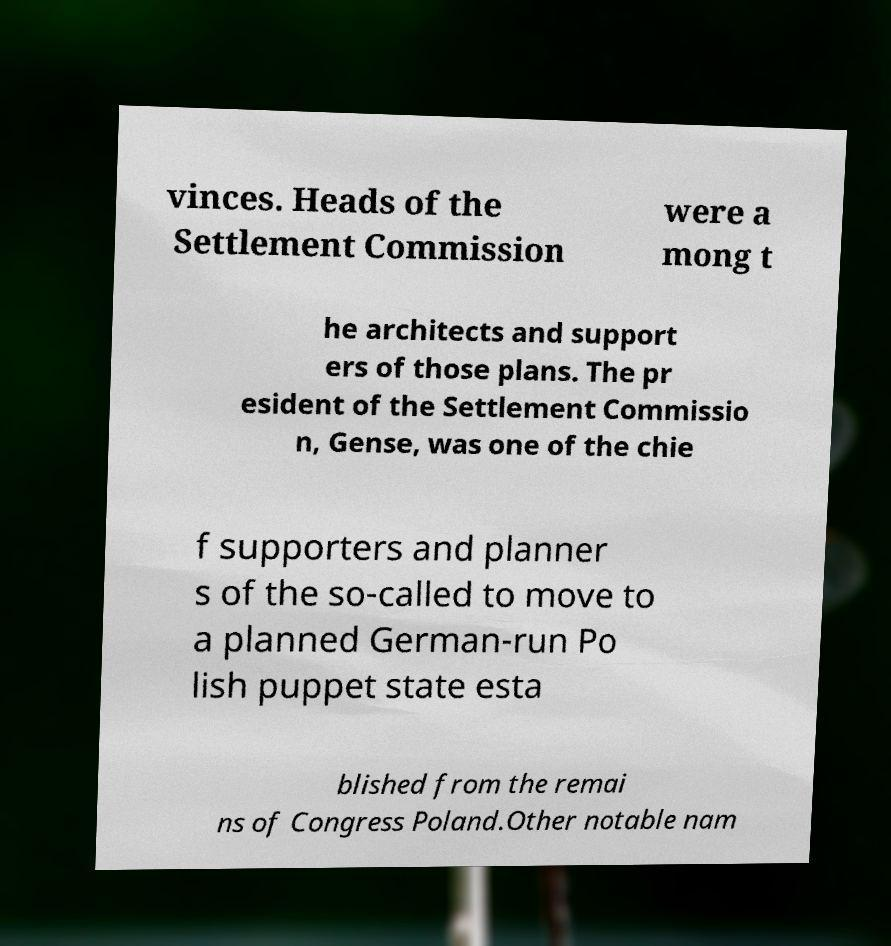Can you read and provide the text displayed in the image?This photo seems to have some interesting text. Can you extract and type it out for me? vinces. Heads of the Settlement Commission were a mong t he architects and support ers of those plans. The pr esident of the Settlement Commissio n, Gense, was one of the chie f supporters and planner s of the so-called to move to a planned German-run Po lish puppet state esta blished from the remai ns of Congress Poland.Other notable nam 